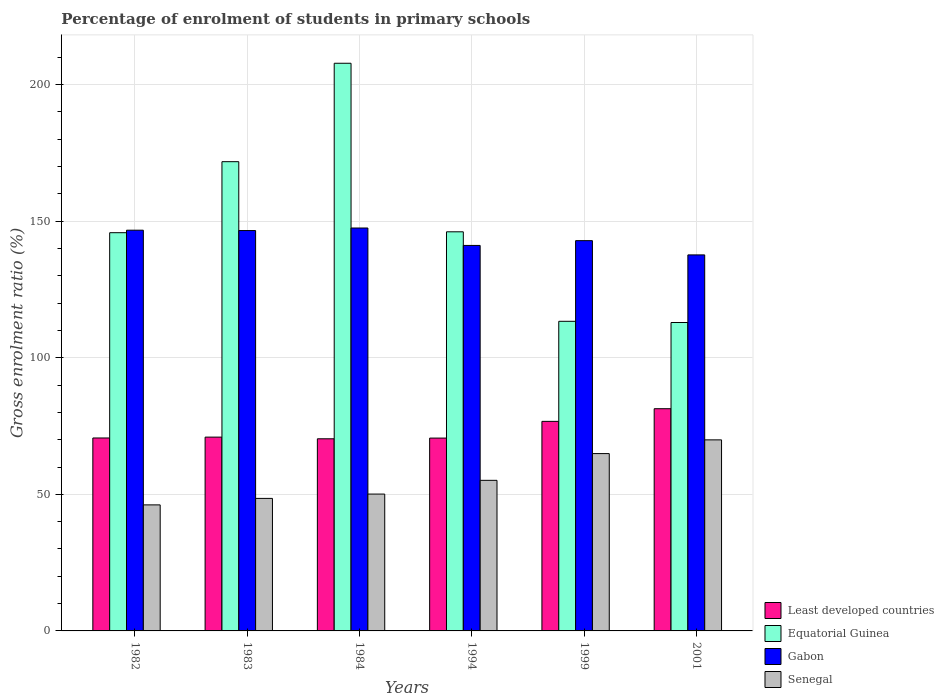How many groups of bars are there?
Your answer should be very brief. 6. Are the number of bars per tick equal to the number of legend labels?
Make the answer very short. Yes. Are the number of bars on each tick of the X-axis equal?
Keep it short and to the point. Yes. How many bars are there on the 6th tick from the left?
Your response must be concise. 4. How many bars are there on the 6th tick from the right?
Your response must be concise. 4. What is the label of the 3rd group of bars from the left?
Make the answer very short. 1984. In how many cases, is the number of bars for a given year not equal to the number of legend labels?
Ensure brevity in your answer.  0. What is the percentage of students enrolled in primary schools in Equatorial Guinea in 1982?
Offer a very short reply. 145.78. Across all years, what is the maximum percentage of students enrolled in primary schools in Equatorial Guinea?
Your response must be concise. 207.82. Across all years, what is the minimum percentage of students enrolled in primary schools in Equatorial Guinea?
Offer a terse response. 112.91. In which year was the percentage of students enrolled in primary schools in Senegal maximum?
Offer a very short reply. 2001. What is the total percentage of students enrolled in primary schools in Least developed countries in the graph?
Offer a very short reply. 440.58. What is the difference between the percentage of students enrolled in primary schools in Least developed countries in 1984 and that in 1999?
Offer a very short reply. -6.38. What is the difference between the percentage of students enrolled in primary schools in Least developed countries in 2001 and the percentage of students enrolled in primary schools in Senegal in 1999?
Make the answer very short. 16.43. What is the average percentage of students enrolled in primary schools in Equatorial Guinea per year?
Your response must be concise. 149.62. In the year 1999, what is the difference between the percentage of students enrolled in primary schools in Least developed countries and percentage of students enrolled in primary schools in Senegal?
Provide a succinct answer. 11.8. What is the ratio of the percentage of students enrolled in primary schools in Senegal in 1982 to that in 1994?
Keep it short and to the point. 0.84. Is the percentage of students enrolled in primary schools in Least developed countries in 1982 less than that in 1984?
Your answer should be compact. No. Is the difference between the percentage of students enrolled in primary schools in Least developed countries in 1984 and 2001 greater than the difference between the percentage of students enrolled in primary schools in Senegal in 1984 and 2001?
Provide a short and direct response. Yes. What is the difference between the highest and the second highest percentage of students enrolled in primary schools in Equatorial Guinea?
Keep it short and to the point. 36.03. What is the difference between the highest and the lowest percentage of students enrolled in primary schools in Least developed countries?
Offer a terse response. 11.01. What does the 2nd bar from the left in 1982 represents?
Keep it short and to the point. Equatorial Guinea. What does the 2nd bar from the right in 1982 represents?
Provide a succinct answer. Gabon. How many bars are there?
Keep it short and to the point. 24. Does the graph contain grids?
Ensure brevity in your answer.  Yes. Where does the legend appear in the graph?
Ensure brevity in your answer.  Bottom right. How are the legend labels stacked?
Your answer should be very brief. Vertical. What is the title of the graph?
Offer a very short reply. Percentage of enrolment of students in primary schools. What is the label or title of the X-axis?
Provide a succinct answer. Years. What is the Gross enrolment ratio (%) of Least developed countries in 1982?
Provide a short and direct response. 70.63. What is the Gross enrolment ratio (%) in Equatorial Guinea in 1982?
Offer a terse response. 145.78. What is the Gross enrolment ratio (%) of Gabon in 1982?
Make the answer very short. 146.7. What is the Gross enrolment ratio (%) in Senegal in 1982?
Your response must be concise. 46.14. What is the Gross enrolment ratio (%) of Least developed countries in 1983?
Your answer should be compact. 70.95. What is the Gross enrolment ratio (%) in Equatorial Guinea in 1983?
Keep it short and to the point. 171.78. What is the Gross enrolment ratio (%) of Gabon in 1983?
Your answer should be compact. 146.57. What is the Gross enrolment ratio (%) of Senegal in 1983?
Your response must be concise. 48.52. What is the Gross enrolment ratio (%) in Least developed countries in 1984?
Make the answer very short. 70.34. What is the Gross enrolment ratio (%) in Equatorial Guinea in 1984?
Your response must be concise. 207.82. What is the Gross enrolment ratio (%) in Gabon in 1984?
Keep it short and to the point. 147.5. What is the Gross enrolment ratio (%) in Senegal in 1984?
Provide a succinct answer. 50.1. What is the Gross enrolment ratio (%) in Least developed countries in 1994?
Keep it short and to the point. 70.6. What is the Gross enrolment ratio (%) in Equatorial Guinea in 1994?
Make the answer very short. 146.11. What is the Gross enrolment ratio (%) in Gabon in 1994?
Your answer should be very brief. 141.12. What is the Gross enrolment ratio (%) in Senegal in 1994?
Your answer should be compact. 55.13. What is the Gross enrolment ratio (%) of Least developed countries in 1999?
Offer a very short reply. 76.72. What is the Gross enrolment ratio (%) of Equatorial Guinea in 1999?
Give a very brief answer. 113.34. What is the Gross enrolment ratio (%) of Gabon in 1999?
Provide a succinct answer. 142.87. What is the Gross enrolment ratio (%) in Senegal in 1999?
Make the answer very short. 64.92. What is the Gross enrolment ratio (%) of Least developed countries in 2001?
Offer a terse response. 81.35. What is the Gross enrolment ratio (%) in Equatorial Guinea in 2001?
Make the answer very short. 112.91. What is the Gross enrolment ratio (%) in Gabon in 2001?
Ensure brevity in your answer.  137.66. What is the Gross enrolment ratio (%) of Senegal in 2001?
Your answer should be compact. 69.94. Across all years, what is the maximum Gross enrolment ratio (%) of Least developed countries?
Offer a very short reply. 81.35. Across all years, what is the maximum Gross enrolment ratio (%) of Equatorial Guinea?
Your answer should be compact. 207.82. Across all years, what is the maximum Gross enrolment ratio (%) of Gabon?
Offer a very short reply. 147.5. Across all years, what is the maximum Gross enrolment ratio (%) in Senegal?
Provide a short and direct response. 69.94. Across all years, what is the minimum Gross enrolment ratio (%) in Least developed countries?
Your answer should be compact. 70.34. Across all years, what is the minimum Gross enrolment ratio (%) of Equatorial Guinea?
Make the answer very short. 112.91. Across all years, what is the minimum Gross enrolment ratio (%) of Gabon?
Give a very brief answer. 137.66. Across all years, what is the minimum Gross enrolment ratio (%) in Senegal?
Ensure brevity in your answer.  46.14. What is the total Gross enrolment ratio (%) of Least developed countries in the graph?
Your response must be concise. 440.58. What is the total Gross enrolment ratio (%) of Equatorial Guinea in the graph?
Give a very brief answer. 897.75. What is the total Gross enrolment ratio (%) of Gabon in the graph?
Your answer should be compact. 862.43. What is the total Gross enrolment ratio (%) in Senegal in the graph?
Give a very brief answer. 334.74. What is the difference between the Gross enrolment ratio (%) in Least developed countries in 1982 and that in 1983?
Your response must be concise. -0.32. What is the difference between the Gross enrolment ratio (%) of Equatorial Guinea in 1982 and that in 1983?
Your response must be concise. -26. What is the difference between the Gross enrolment ratio (%) in Gabon in 1982 and that in 1983?
Ensure brevity in your answer.  0.13. What is the difference between the Gross enrolment ratio (%) of Senegal in 1982 and that in 1983?
Your answer should be very brief. -2.37. What is the difference between the Gross enrolment ratio (%) of Least developed countries in 1982 and that in 1984?
Your answer should be compact. 0.3. What is the difference between the Gross enrolment ratio (%) in Equatorial Guinea in 1982 and that in 1984?
Offer a very short reply. -62.03. What is the difference between the Gross enrolment ratio (%) in Gabon in 1982 and that in 1984?
Offer a very short reply. -0.8. What is the difference between the Gross enrolment ratio (%) in Senegal in 1982 and that in 1984?
Give a very brief answer. -3.96. What is the difference between the Gross enrolment ratio (%) in Least developed countries in 1982 and that in 1994?
Offer a very short reply. 0.04. What is the difference between the Gross enrolment ratio (%) in Equatorial Guinea in 1982 and that in 1994?
Give a very brief answer. -0.33. What is the difference between the Gross enrolment ratio (%) in Gabon in 1982 and that in 1994?
Make the answer very short. 5.58. What is the difference between the Gross enrolment ratio (%) of Senegal in 1982 and that in 1994?
Provide a succinct answer. -8.99. What is the difference between the Gross enrolment ratio (%) in Least developed countries in 1982 and that in 1999?
Your response must be concise. -6.08. What is the difference between the Gross enrolment ratio (%) in Equatorial Guinea in 1982 and that in 1999?
Ensure brevity in your answer.  32.44. What is the difference between the Gross enrolment ratio (%) in Gabon in 1982 and that in 1999?
Ensure brevity in your answer.  3.83. What is the difference between the Gross enrolment ratio (%) of Senegal in 1982 and that in 1999?
Provide a short and direct response. -18.78. What is the difference between the Gross enrolment ratio (%) of Least developed countries in 1982 and that in 2001?
Your answer should be very brief. -10.72. What is the difference between the Gross enrolment ratio (%) in Equatorial Guinea in 1982 and that in 2001?
Make the answer very short. 32.88. What is the difference between the Gross enrolment ratio (%) in Gabon in 1982 and that in 2001?
Offer a terse response. 9.05. What is the difference between the Gross enrolment ratio (%) in Senegal in 1982 and that in 2001?
Provide a short and direct response. -23.8. What is the difference between the Gross enrolment ratio (%) in Least developed countries in 1983 and that in 1984?
Your answer should be compact. 0.61. What is the difference between the Gross enrolment ratio (%) in Equatorial Guinea in 1983 and that in 1984?
Provide a short and direct response. -36.03. What is the difference between the Gross enrolment ratio (%) of Gabon in 1983 and that in 1984?
Offer a terse response. -0.93. What is the difference between the Gross enrolment ratio (%) in Senegal in 1983 and that in 1984?
Your answer should be compact. -1.59. What is the difference between the Gross enrolment ratio (%) in Least developed countries in 1983 and that in 1994?
Your answer should be very brief. 0.35. What is the difference between the Gross enrolment ratio (%) in Equatorial Guinea in 1983 and that in 1994?
Offer a terse response. 25.67. What is the difference between the Gross enrolment ratio (%) in Gabon in 1983 and that in 1994?
Your response must be concise. 5.45. What is the difference between the Gross enrolment ratio (%) of Senegal in 1983 and that in 1994?
Your answer should be very brief. -6.61. What is the difference between the Gross enrolment ratio (%) of Least developed countries in 1983 and that in 1999?
Offer a terse response. -5.76. What is the difference between the Gross enrolment ratio (%) in Equatorial Guinea in 1983 and that in 1999?
Ensure brevity in your answer.  58.44. What is the difference between the Gross enrolment ratio (%) of Gabon in 1983 and that in 1999?
Provide a short and direct response. 3.7. What is the difference between the Gross enrolment ratio (%) of Senegal in 1983 and that in 1999?
Your answer should be compact. -16.4. What is the difference between the Gross enrolment ratio (%) of Least developed countries in 1983 and that in 2001?
Your answer should be compact. -10.4. What is the difference between the Gross enrolment ratio (%) of Equatorial Guinea in 1983 and that in 2001?
Your answer should be compact. 58.88. What is the difference between the Gross enrolment ratio (%) in Gabon in 1983 and that in 2001?
Offer a very short reply. 8.92. What is the difference between the Gross enrolment ratio (%) of Senegal in 1983 and that in 2001?
Your answer should be very brief. -21.43. What is the difference between the Gross enrolment ratio (%) in Least developed countries in 1984 and that in 1994?
Give a very brief answer. -0.26. What is the difference between the Gross enrolment ratio (%) of Equatorial Guinea in 1984 and that in 1994?
Offer a terse response. 61.7. What is the difference between the Gross enrolment ratio (%) of Gabon in 1984 and that in 1994?
Ensure brevity in your answer.  6.38. What is the difference between the Gross enrolment ratio (%) in Senegal in 1984 and that in 1994?
Your answer should be compact. -5.02. What is the difference between the Gross enrolment ratio (%) of Least developed countries in 1984 and that in 1999?
Provide a short and direct response. -6.38. What is the difference between the Gross enrolment ratio (%) in Equatorial Guinea in 1984 and that in 1999?
Provide a short and direct response. 94.47. What is the difference between the Gross enrolment ratio (%) of Gabon in 1984 and that in 1999?
Offer a terse response. 4.63. What is the difference between the Gross enrolment ratio (%) in Senegal in 1984 and that in 1999?
Keep it short and to the point. -14.82. What is the difference between the Gross enrolment ratio (%) in Least developed countries in 1984 and that in 2001?
Keep it short and to the point. -11.01. What is the difference between the Gross enrolment ratio (%) of Equatorial Guinea in 1984 and that in 2001?
Ensure brevity in your answer.  94.91. What is the difference between the Gross enrolment ratio (%) of Gabon in 1984 and that in 2001?
Ensure brevity in your answer.  9.85. What is the difference between the Gross enrolment ratio (%) of Senegal in 1984 and that in 2001?
Your answer should be very brief. -19.84. What is the difference between the Gross enrolment ratio (%) in Least developed countries in 1994 and that in 1999?
Your response must be concise. -6.12. What is the difference between the Gross enrolment ratio (%) of Equatorial Guinea in 1994 and that in 1999?
Provide a succinct answer. 32.77. What is the difference between the Gross enrolment ratio (%) in Gabon in 1994 and that in 1999?
Make the answer very short. -1.75. What is the difference between the Gross enrolment ratio (%) of Senegal in 1994 and that in 1999?
Your answer should be very brief. -9.79. What is the difference between the Gross enrolment ratio (%) in Least developed countries in 1994 and that in 2001?
Your response must be concise. -10.75. What is the difference between the Gross enrolment ratio (%) in Equatorial Guinea in 1994 and that in 2001?
Make the answer very short. 33.21. What is the difference between the Gross enrolment ratio (%) in Gabon in 1994 and that in 2001?
Ensure brevity in your answer.  3.47. What is the difference between the Gross enrolment ratio (%) in Senegal in 1994 and that in 2001?
Ensure brevity in your answer.  -14.82. What is the difference between the Gross enrolment ratio (%) of Least developed countries in 1999 and that in 2001?
Offer a terse response. -4.63. What is the difference between the Gross enrolment ratio (%) in Equatorial Guinea in 1999 and that in 2001?
Offer a very short reply. 0.44. What is the difference between the Gross enrolment ratio (%) in Gabon in 1999 and that in 2001?
Your answer should be compact. 5.22. What is the difference between the Gross enrolment ratio (%) in Senegal in 1999 and that in 2001?
Offer a terse response. -5.02. What is the difference between the Gross enrolment ratio (%) of Least developed countries in 1982 and the Gross enrolment ratio (%) of Equatorial Guinea in 1983?
Your response must be concise. -101.15. What is the difference between the Gross enrolment ratio (%) of Least developed countries in 1982 and the Gross enrolment ratio (%) of Gabon in 1983?
Give a very brief answer. -75.94. What is the difference between the Gross enrolment ratio (%) of Least developed countries in 1982 and the Gross enrolment ratio (%) of Senegal in 1983?
Provide a short and direct response. 22.12. What is the difference between the Gross enrolment ratio (%) in Equatorial Guinea in 1982 and the Gross enrolment ratio (%) in Gabon in 1983?
Keep it short and to the point. -0.79. What is the difference between the Gross enrolment ratio (%) in Equatorial Guinea in 1982 and the Gross enrolment ratio (%) in Senegal in 1983?
Provide a short and direct response. 97.27. What is the difference between the Gross enrolment ratio (%) in Gabon in 1982 and the Gross enrolment ratio (%) in Senegal in 1983?
Your response must be concise. 98.19. What is the difference between the Gross enrolment ratio (%) of Least developed countries in 1982 and the Gross enrolment ratio (%) of Equatorial Guinea in 1984?
Your answer should be compact. -137.18. What is the difference between the Gross enrolment ratio (%) of Least developed countries in 1982 and the Gross enrolment ratio (%) of Gabon in 1984?
Make the answer very short. -76.87. What is the difference between the Gross enrolment ratio (%) in Least developed countries in 1982 and the Gross enrolment ratio (%) in Senegal in 1984?
Your response must be concise. 20.53. What is the difference between the Gross enrolment ratio (%) in Equatorial Guinea in 1982 and the Gross enrolment ratio (%) in Gabon in 1984?
Give a very brief answer. -1.72. What is the difference between the Gross enrolment ratio (%) of Equatorial Guinea in 1982 and the Gross enrolment ratio (%) of Senegal in 1984?
Provide a succinct answer. 95.68. What is the difference between the Gross enrolment ratio (%) of Gabon in 1982 and the Gross enrolment ratio (%) of Senegal in 1984?
Your answer should be compact. 96.6. What is the difference between the Gross enrolment ratio (%) of Least developed countries in 1982 and the Gross enrolment ratio (%) of Equatorial Guinea in 1994?
Your answer should be very brief. -75.48. What is the difference between the Gross enrolment ratio (%) of Least developed countries in 1982 and the Gross enrolment ratio (%) of Gabon in 1994?
Ensure brevity in your answer.  -70.49. What is the difference between the Gross enrolment ratio (%) in Least developed countries in 1982 and the Gross enrolment ratio (%) in Senegal in 1994?
Offer a very short reply. 15.51. What is the difference between the Gross enrolment ratio (%) of Equatorial Guinea in 1982 and the Gross enrolment ratio (%) of Gabon in 1994?
Ensure brevity in your answer.  4.66. What is the difference between the Gross enrolment ratio (%) in Equatorial Guinea in 1982 and the Gross enrolment ratio (%) in Senegal in 1994?
Offer a very short reply. 90.66. What is the difference between the Gross enrolment ratio (%) in Gabon in 1982 and the Gross enrolment ratio (%) in Senegal in 1994?
Your answer should be compact. 91.58. What is the difference between the Gross enrolment ratio (%) of Least developed countries in 1982 and the Gross enrolment ratio (%) of Equatorial Guinea in 1999?
Offer a very short reply. -42.71. What is the difference between the Gross enrolment ratio (%) in Least developed countries in 1982 and the Gross enrolment ratio (%) in Gabon in 1999?
Provide a short and direct response. -72.24. What is the difference between the Gross enrolment ratio (%) of Least developed countries in 1982 and the Gross enrolment ratio (%) of Senegal in 1999?
Offer a very short reply. 5.71. What is the difference between the Gross enrolment ratio (%) of Equatorial Guinea in 1982 and the Gross enrolment ratio (%) of Gabon in 1999?
Keep it short and to the point. 2.91. What is the difference between the Gross enrolment ratio (%) in Equatorial Guinea in 1982 and the Gross enrolment ratio (%) in Senegal in 1999?
Offer a very short reply. 80.87. What is the difference between the Gross enrolment ratio (%) of Gabon in 1982 and the Gross enrolment ratio (%) of Senegal in 1999?
Ensure brevity in your answer.  81.79. What is the difference between the Gross enrolment ratio (%) in Least developed countries in 1982 and the Gross enrolment ratio (%) in Equatorial Guinea in 2001?
Make the answer very short. -42.27. What is the difference between the Gross enrolment ratio (%) of Least developed countries in 1982 and the Gross enrolment ratio (%) of Gabon in 2001?
Keep it short and to the point. -67.02. What is the difference between the Gross enrolment ratio (%) of Least developed countries in 1982 and the Gross enrolment ratio (%) of Senegal in 2001?
Ensure brevity in your answer.  0.69. What is the difference between the Gross enrolment ratio (%) of Equatorial Guinea in 1982 and the Gross enrolment ratio (%) of Gabon in 2001?
Ensure brevity in your answer.  8.13. What is the difference between the Gross enrolment ratio (%) in Equatorial Guinea in 1982 and the Gross enrolment ratio (%) in Senegal in 2001?
Make the answer very short. 75.84. What is the difference between the Gross enrolment ratio (%) of Gabon in 1982 and the Gross enrolment ratio (%) of Senegal in 2001?
Give a very brief answer. 76.76. What is the difference between the Gross enrolment ratio (%) in Least developed countries in 1983 and the Gross enrolment ratio (%) in Equatorial Guinea in 1984?
Give a very brief answer. -136.86. What is the difference between the Gross enrolment ratio (%) in Least developed countries in 1983 and the Gross enrolment ratio (%) in Gabon in 1984?
Give a very brief answer. -76.55. What is the difference between the Gross enrolment ratio (%) of Least developed countries in 1983 and the Gross enrolment ratio (%) of Senegal in 1984?
Make the answer very short. 20.85. What is the difference between the Gross enrolment ratio (%) in Equatorial Guinea in 1983 and the Gross enrolment ratio (%) in Gabon in 1984?
Give a very brief answer. 24.28. What is the difference between the Gross enrolment ratio (%) of Equatorial Guinea in 1983 and the Gross enrolment ratio (%) of Senegal in 1984?
Your answer should be compact. 121.68. What is the difference between the Gross enrolment ratio (%) of Gabon in 1983 and the Gross enrolment ratio (%) of Senegal in 1984?
Offer a very short reply. 96.47. What is the difference between the Gross enrolment ratio (%) of Least developed countries in 1983 and the Gross enrolment ratio (%) of Equatorial Guinea in 1994?
Make the answer very short. -75.16. What is the difference between the Gross enrolment ratio (%) of Least developed countries in 1983 and the Gross enrolment ratio (%) of Gabon in 1994?
Give a very brief answer. -70.17. What is the difference between the Gross enrolment ratio (%) in Least developed countries in 1983 and the Gross enrolment ratio (%) in Senegal in 1994?
Keep it short and to the point. 15.82. What is the difference between the Gross enrolment ratio (%) of Equatorial Guinea in 1983 and the Gross enrolment ratio (%) of Gabon in 1994?
Your answer should be compact. 30.66. What is the difference between the Gross enrolment ratio (%) in Equatorial Guinea in 1983 and the Gross enrolment ratio (%) in Senegal in 1994?
Keep it short and to the point. 116.66. What is the difference between the Gross enrolment ratio (%) in Gabon in 1983 and the Gross enrolment ratio (%) in Senegal in 1994?
Your response must be concise. 91.45. What is the difference between the Gross enrolment ratio (%) of Least developed countries in 1983 and the Gross enrolment ratio (%) of Equatorial Guinea in 1999?
Ensure brevity in your answer.  -42.39. What is the difference between the Gross enrolment ratio (%) of Least developed countries in 1983 and the Gross enrolment ratio (%) of Gabon in 1999?
Give a very brief answer. -71.92. What is the difference between the Gross enrolment ratio (%) in Least developed countries in 1983 and the Gross enrolment ratio (%) in Senegal in 1999?
Keep it short and to the point. 6.03. What is the difference between the Gross enrolment ratio (%) in Equatorial Guinea in 1983 and the Gross enrolment ratio (%) in Gabon in 1999?
Provide a short and direct response. 28.91. What is the difference between the Gross enrolment ratio (%) in Equatorial Guinea in 1983 and the Gross enrolment ratio (%) in Senegal in 1999?
Provide a short and direct response. 106.86. What is the difference between the Gross enrolment ratio (%) in Gabon in 1983 and the Gross enrolment ratio (%) in Senegal in 1999?
Keep it short and to the point. 81.65. What is the difference between the Gross enrolment ratio (%) of Least developed countries in 1983 and the Gross enrolment ratio (%) of Equatorial Guinea in 2001?
Offer a terse response. -41.95. What is the difference between the Gross enrolment ratio (%) of Least developed countries in 1983 and the Gross enrolment ratio (%) of Gabon in 2001?
Offer a terse response. -66.71. What is the difference between the Gross enrolment ratio (%) of Least developed countries in 1983 and the Gross enrolment ratio (%) of Senegal in 2001?
Your answer should be compact. 1.01. What is the difference between the Gross enrolment ratio (%) of Equatorial Guinea in 1983 and the Gross enrolment ratio (%) of Gabon in 2001?
Your response must be concise. 34.13. What is the difference between the Gross enrolment ratio (%) of Equatorial Guinea in 1983 and the Gross enrolment ratio (%) of Senegal in 2001?
Make the answer very short. 101.84. What is the difference between the Gross enrolment ratio (%) of Gabon in 1983 and the Gross enrolment ratio (%) of Senegal in 2001?
Keep it short and to the point. 76.63. What is the difference between the Gross enrolment ratio (%) in Least developed countries in 1984 and the Gross enrolment ratio (%) in Equatorial Guinea in 1994?
Provide a short and direct response. -75.78. What is the difference between the Gross enrolment ratio (%) in Least developed countries in 1984 and the Gross enrolment ratio (%) in Gabon in 1994?
Your answer should be very brief. -70.79. What is the difference between the Gross enrolment ratio (%) of Least developed countries in 1984 and the Gross enrolment ratio (%) of Senegal in 1994?
Provide a short and direct response. 15.21. What is the difference between the Gross enrolment ratio (%) of Equatorial Guinea in 1984 and the Gross enrolment ratio (%) of Gabon in 1994?
Offer a terse response. 66.69. What is the difference between the Gross enrolment ratio (%) of Equatorial Guinea in 1984 and the Gross enrolment ratio (%) of Senegal in 1994?
Your answer should be compact. 152.69. What is the difference between the Gross enrolment ratio (%) of Gabon in 1984 and the Gross enrolment ratio (%) of Senegal in 1994?
Ensure brevity in your answer.  92.38. What is the difference between the Gross enrolment ratio (%) of Least developed countries in 1984 and the Gross enrolment ratio (%) of Equatorial Guinea in 1999?
Ensure brevity in your answer.  -43.01. What is the difference between the Gross enrolment ratio (%) of Least developed countries in 1984 and the Gross enrolment ratio (%) of Gabon in 1999?
Keep it short and to the point. -72.54. What is the difference between the Gross enrolment ratio (%) in Least developed countries in 1984 and the Gross enrolment ratio (%) in Senegal in 1999?
Your answer should be very brief. 5.42. What is the difference between the Gross enrolment ratio (%) in Equatorial Guinea in 1984 and the Gross enrolment ratio (%) in Gabon in 1999?
Make the answer very short. 64.94. What is the difference between the Gross enrolment ratio (%) of Equatorial Guinea in 1984 and the Gross enrolment ratio (%) of Senegal in 1999?
Ensure brevity in your answer.  142.9. What is the difference between the Gross enrolment ratio (%) in Gabon in 1984 and the Gross enrolment ratio (%) in Senegal in 1999?
Offer a terse response. 82.58. What is the difference between the Gross enrolment ratio (%) in Least developed countries in 1984 and the Gross enrolment ratio (%) in Equatorial Guinea in 2001?
Your answer should be very brief. -42.57. What is the difference between the Gross enrolment ratio (%) of Least developed countries in 1984 and the Gross enrolment ratio (%) of Gabon in 2001?
Keep it short and to the point. -67.32. What is the difference between the Gross enrolment ratio (%) in Least developed countries in 1984 and the Gross enrolment ratio (%) in Senegal in 2001?
Make the answer very short. 0.39. What is the difference between the Gross enrolment ratio (%) of Equatorial Guinea in 1984 and the Gross enrolment ratio (%) of Gabon in 2001?
Your answer should be compact. 70.16. What is the difference between the Gross enrolment ratio (%) of Equatorial Guinea in 1984 and the Gross enrolment ratio (%) of Senegal in 2001?
Your answer should be compact. 137.87. What is the difference between the Gross enrolment ratio (%) of Gabon in 1984 and the Gross enrolment ratio (%) of Senegal in 2001?
Provide a succinct answer. 77.56. What is the difference between the Gross enrolment ratio (%) in Least developed countries in 1994 and the Gross enrolment ratio (%) in Equatorial Guinea in 1999?
Your answer should be compact. -42.75. What is the difference between the Gross enrolment ratio (%) of Least developed countries in 1994 and the Gross enrolment ratio (%) of Gabon in 1999?
Keep it short and to the point. -72.28. What is the difference between the Gross enrolment ratio (%) of Least developed countries in 1994 and the Gross enrolment ratio (%) of Senegal in 1999?
Ensure brevity in your answer.  5.68. What is the difference between the Gross enrolment ratio (%) of Equatorial Guinea in 1994 and the Gross enrolment ratio (%) of Gabon in 1999?
Offer a terse response. 3.24. What is the difference between the Gross enrolment ratio (%) in Equatorial Guinea in 1994 and the Gross enrolment ratio (%) in Senegal in 1999?
Your answer should be compact. 81.19. What is the difference between the Gross enrolment ratio (%) of Gabon in 1994 and the Gross enrolment ratio (%) of Senegal in 1999?
Ensure brevity in your answer.  76.2. What is the difference between the Gross enrolment ratio (%) of Least developed countries in 1994 and the Gross enrolment ratio (%) of Equatorial Guinea in 2001?
Keep it short and to the point. -42.31. What is the difference between the Gross enrolment ratio (%) of Least developed countries in 1994 and the Gross enrolment ratio (%) of Gabon in 2001?
Ensure brevity in your answer.  -67.06. What is the difference between the Gross enrolment ratio (%) of Least developed countries in 1994 and the Gross enrolment ratio (%) of Senegal in 2001?
Offer a very short reply. 0.66. What is the difference between the Gross enrolment ratio (%) in Equatorial Guinea in 1994 and the Gross enrolment ratio (%) in Gabon in 2001?
Your response must be concise. 8.46. What is the difference between the Gross enrolment ratio (%) of Equatorial Guinea in 1994 and the Gross enrolment ratio (%) of Senegal in 2001?
Give a very brief answer. 76.17. What is the difference between the Gross enrolment ratio (%) of Gabon in 1994 and the Gross enrolment ratio (%) of Senegal in 2001?
Provide a succinct answer. 71.18. What is the difference between the Gross enrolment ratio (%) in Least developed countries in 1999 and the Gross enrolment ratio (%) in Equatorial Guinea in 2001?
Your answer should be very brief. -36.19. What is the difference between the Gross enrolment ratio (%) of Least developed countries in 1999 and the Gross enrolment ratio (%) of Gabon in 2001?
Keep it short and to the point. -60.94. What is the difference between the Gross enrolment ratio (%) in Least developed countries in 1999 and the Gross enrolment ratio (%) in Senegal in 2001?
Make the answer very short. 6.77. What is the difference between the Gross enrolment ratio (%) in Equatorial Guinea in 1999 and the Gross enrolment ratio (%) in Gabon in 2001?
Make the answer very short. -24.31. What is the difference between the Gross enrolment ratio (%) in Equatorial Guinea in 1999 and the Gross enrolment ratio (%) in Senegal in 2001?
Make the answer very short. 43.4. What is the difference between the Gross enrolment ratio (%) in Gabon in 1999 and the Gross enrolment ratio (%) in Senegal in 2001?
Give a very brief answer. 72.93. What is the average Gross enrolment ratio (%) of Least developed countries per year?
Ensure brevity in your answer.  73.43. What is the average Gross enrolment ratio (%) of Equatorial Guinea per year?
Offer a very short reply. 149.62. What is the average Gross enrolment ratio (%) of Gabon per year?
Give a very brief answer. 143.74. What is the average Gross enrolment ratio (%) in Senegal per year?
Give a very brief answer. 55.79. In the year 1982, what is the difference between the Gross enrolment ratio (%) of Least developed countries and Gross enrolment ratio (%) of Equatorial Guinea?
Provide a short and direct response. -75.15. In the year 1982, what is the difference between the Gross enrolment ratio (%) of Least developed countries and Gross enrolment ratio (%) of Gabon?
Give a very brief answer. -76.07. In the year 1982, what is the difference between the Gross enrolment ratio (%) in Least developed countries and Gross enrolment ratio (%) in Senegal?
Your response must be concise. 24.49. In the year 1982, what is the difference between the Gross enrolment ratio (%) in Equatorial Guinea and Gross enrolment ratio (%) in Gabon?
Your answer should be very brief. -0.92. In the year 1982, what is the difference between the Gross enrolment ratio (%) in Equatorial Guinea and Gross enrolment ratio (%) in Senegal?
Your answer should be very brief. 99.64. In the year 1982, what is the difference between the Gross enrolment ratio (%) of Gabon and Gross enrolment ratio (%) of Senegal?
Offer a very short reply. 100.56. In the year 1983, what is the difference between the Gross enrolment ratio (%) of Least developed countries and Gross enrolment ratio (%) of Equatorial Guinea?
Offer a terse response. -100.83. In the year 1983, what is the difference between the Gross enrolment ratio (%) of Least developed countries and Gross enrolment ratio (%) of Gabon?
Keep it short and to the point. -75.62. In the year 1983, what is the difference between the Gross enrolment ratio (%) in Least developed countries and Gross enrolment ratio (%) in Senegal?
Offer a very short reply. 22.44. In the year 1983, what is the difference between the Gross enrolment ratio (%) in Equatorial Guinea and Gross enrolment ratio (%) in Gabon?
Offer a terse response. 25.21. In the year 1983, what is the difference between the Gross enrolment ratio (%) in Equatorial Guinea and Gross enrolment ratio (%) in Senegal?
Offer a very short reply. 123.27. In the year 1983, what is the difference between the Gross enrolment ratio (%) of Gabon and Gross enrolment ratio (%) of Senegal?
Your response must be concise. 98.06. In the year 1984, what is the difference between the Gross enrolment ratio (%) of Least developed countries and Gross enrolment ratio (%) of Equatorial Guinea?
Your response must be concise. -137.48. In the year 1984, what is the difference between the Gross enrolment ratio (%) in Least developed countries and Gross enrolment ratio (%) in Gabon?
Offer a terse response. -77.17. In the year 1984, what is the difference between the Gross enrolment ratio (%) in Least developed countries and Gross enrolment ratio (%) in Senegal?
Make the answer very short. 20.23. In the year 1984, what is the difference between the Gross enrolment ratio (%) of Equatorial Guinea and Gross enrolment ratio (%) of Gabon?
Provide a short and direct response. 60.31. In the year 1984, what is the difference between the Gross enrolment ratio (%) of Equatorial Guinea and Gross enrolment ratio (%) of Senegal?
Provide a short and direct response. 157.71. In the year 1984, what is the difference between the Gross enrolment ratio (%) in Gabon and Gross enrolment ratio (%) in Senegal?
Offer a terse response. 97.4. In the year 1994, what is the difference between the Gross enrolment ratio (%) in Least developed countries and Gross enrolment ratio (%) in Equatorial Guinea?
Make the answer very short. -75.52. In the year 1994, what is the difference between the Gross enrolment ratio (%) in Least developed countries and Gross enrolment ratio (%) in Gabon?
Offer a very short reply. -70.53. In the year 1994, what is the difference between the Gross enrolment ratio (%) of Least developed countries and Gross enrolment ratio (%) of Senegal?
Your answer should be very brief. 15.47. In the year 1994, what is the difference between the Gross enrolment ratio (%) of Equatorial Guinea and Gross enrolment ratio (%) of Gabon?
Provide a succinct answer. 4.99. In the year 1994, what is the difference between the Gross enrolment ratio (%) of Equatorial Guinea and Gross enrolment ratio (%) of Senegal?
Your answer should be very brief. 90.99. In the year 1994, what is the difference between the Gross enrolment ratio (%) in Gabon and Gross enrolment ratio (%) in Senegal?
Offer a very short reply. 86. In the year 1999, what is the difference between the Gross enrolment ratio (%) of Least developed countries and Gross enrolment ratio (%) of Equatorial Guinea?
Make the answer very short. -36.63. In the year 1999, what is the difference between the Gross enrolment ratio (%) of Least developed countries and Gross enrolment ratio (%) of Gabon?
Keep it short and to the point. -66.16. In the year 1999, what is the difference between the Gross enrolment ratio (%) in Least developed countries and Gross enrolment ratio (%) in Senegal?
Give a very brief answer. 11.8. In the year 1999, what is the difference between the Gross enrolment ratio (%) in Equatorial Guinea and Gross enrolment ratio (%) in Gabon?
Offer a terse response. -29.53. In the year 1999, what is the difference between the Gross enrolment ratio (%) of Equatorial Guinea and Gross enrolment ratio (%) of Senegal?
Your response must be concise. 48.43. In the year 1999, what is the difference between the Gross enrolment ratio (%) in Gabon and Gross enrolment ratio (%) in Senegal?
Your answer should be very brief. 77.96. In the year 2001, what is the difference between the Gross enrolment ratio (%) in Least developed countries and Gross enrolment ratio (%) in Equatorial Guinea?
Your answer should be compact. -31.56. In the year 2001, what is the difference between the Gross enrolment ratio (%) in Least developed countries and Gross enrolment ratio (%) in Gabon?
Provide a succinct answer. -56.31. In the year 2001, what is the difference between the Gross enrolment ratio (%) in Least developed countries and Gross enrolment ratio (%) in Senegal?
Your answer should be compact. 11.41. In the year 2001, what is the difference between the Gross enrolment ratio (%) in Equatorial Guinea and Gross enrolment ratio (%) in Gabon?
Offer a very short reply. -24.75. In the year 2001, what is the difference between the Gross enrolment ratio (%) in Equatorial Guinea and Gross enrolment ratio (%) in Senegal?
Give a very brief answer. 42.96. In the year 2001, what is the difference between the Gross enrolment ratio (%) of Gabon and Gross enrolment ratio (%) of Senegal?
Offer a very short reply. 67.71. What is the ratio of the Gross enrolment ratio (%) of Least developed countries in 1982 to that in 1983?
Provide a short and direct response. 1. What is the ratio of the Gross enrolment ratio (%) of Equatorial Guinea in 1982 to that in 1983?
Ensure brevity in your answer.  0.85. What is the ratio of the Gross enrolment ratio (%) in Gabon in 1982 to that in 1983?
Your answer should be compact. 1. What is the ratio of the Gross enrolment ratio (%) of Senegal in 1982 to that in 1983?
Make the answer very short. 0.95. What is the ratio of the Gross enrolment ratio (%) in Least developed countries in 1982 to that in 1984?
Your response must be concise. 1. What is the ratio of the Gross enrolment ratio (%) of Equatorial Guinea in 1982 to that in 1984?
Make the answer very short. 0.7. What is the ratio of the Gross enrolment ratio (%) in Gabon in 1982 to that in 1984?
Your answer should be very brief. 0.99. What is the ratio of the Gross enrolment ratio (%) of Senegal in 1982 to that in 1984?
Your answer should be compact. 0.92. What is the ratio of the Gross enrolment ratio (%) in Equatorial Guinea in 1982 to that in 1994?
Make the answer very short. 1. What is the ratio of the Gross enrolment ratio (%) in Gabon in 1982 to that in 1994?
Provide a short and direct response. 1.04. What is the ratio of the Gross enrolment ratio (%) of Senegal in 1982 to that in 1994?
Provide a short and direct response. 0.84. What is the ratio of the Gross enrolment ratio (%) of Least developed countries in 1982 to that in 1999?
Your answer should be very brief. 0.92. What is the ratio of the Gross enrolment ratio (%) in Equatorial Guinea in 1982 to that in 1999?
Offer a terse response. 1.29. What is the ratio of the Gross enrolment ratio (%) of Gabon in 1982 to that in 1999?
Offer a very short reply. 1.03. What is the ratio of the Gross enrolment ratio (%) in Senegal in 1982 to that in 1999?
Keep it short and to the point. 0.71. What is the ratio of the Gross enrolment ratio (%) in Least developed countries in 1982 to that in 2001?
Offer a very short reply. 0.87. What is the ratio of the Gross enrolment ratio (%) of Equatorial Guinea in 1982 to that in 2001?
Make the answer very short. 1.29. What is the ratio of the Gross enrolment ratio (%) in Gabon in 1982 to that in 2001?
Provide a succinct answer. 1.07. What is the ratio of the Gross enrolment ratio (%) of Senegal in 1982 to that in 2001?
Provide a short and direct response. 0.66. What is the ratio of the Gross enrolment ratio (%) in Least developed countries in 1983 to that in 1984?
Offer a terse response. 1.01. What is the ratio of the Gross enrolment ratio (%) of Equatorial Guinea in 1983 to that in 1984?
Give a very brief answer. 0.83. What is the ratio of the Gross enrolment ratio (%) of Gabon in 1983 to that in 1984?
Keep it short and to the point. 0.99. What is the ratio of the Gross enrolment ratio (%) of Senegal in 1983 to that in 1984?
Offer a terse response. 0.97. What is the ratio of the Gross enrolment ratio (%) in Equatorial Guinea in 1983 to that in 1994?
Your answer should be very brief. 1.18. What is the ratio of the Gross enrolment ratio (%) in Gabon in 1983 to that in 1994?
Provide a succinct answer. 1.04. What is the ratio of the Gross enrolment ratio (%) in Senegal in 1983 to that in 1994?
Make the answer very short. 0.88. What is the ratio of the Gross enrolment ratio (%) of Least developed countries in 1983 to that in 1999?
Your response must be concise. 0.92. What is the ratio of the Gross enrolment ratio (%) in Equatorial Guinea in 1983 to that in 1999?
Provide a short and direct response. 1.52. What is the ratio of the Gross enrolment ratio (%) in Gabon in 1983 to that in 1999?
Give a very brief answer. 1.03. What is the ratio of the Gross enrolment ratio (%) in Senegal in 1983 to that in 1999?
Provide a succinct answer. 0.75. What is the ratio of the Gross enrolment ratio (%) of Least developed countries in 1983 to that in 2001?
Your response must be concise. 0.87. What is the ratio of the Gross enrolment ratio (%) of Equatorial Guinea in 1983 to that in 2001?
Give a very brief answer. 1.52. What is the ratio of the Gross enrolment ratio (%) of Gabon in 1983 to that in 2001?
Your answer should be compact. 1.06. What is the ratio of the Gross enrolment ratio (%) of Senegal in 1983 to that in 2001?
Make the answer very short. 0.69. What is the ratio of the Gross enrolment ratio (%) of Least developed countries in 1984 to that in 1994?
Keep it short and to the point. 1. What is the ratio of the Gross enrolment ratio (%) of Equatorial Guinea in 1984 to that in 1994?
Make the answer very short. 1.42. What is the ratio of the Gross enrolment ratio (%) in Gabon in 1984 to that in 1994?
Your response must be concise. 1.05. What is the ratio of the Gross enrolment ratio (%) in Senegal in 1984 to that in 1994?
Keep it short and to the point. 0.91. What is the ratio of the Gross enrolment ratio (%) in Least developed countries in 1984 to that in 1999?
Provide a short and direct response. 0.92. What is the ratio of the Gross enrolment ratio (%) in Equatorial Guinea in 1984 to that in 1999?
Keep it short and to the point. 1.83. What is the ratio of the Gross enrolment ratio (%) in Gabon in 1984 to that in 1999?
Keep it short and to the point. 1.03. What is the ratio of the Gross enrolment ratio (%) in Senegal in 1984 to that in 1999?
Your answer should be very brief. 0.77. What is the ratio of the Gross enrolment ratio (%) of Least developed countries in 1984 to that in 2001?
Offer a very short reply. 0.86. What is the ratio of the Gross enrolment ratio (%) in Equatorial Guinea in 1984 to that in 2001?
Give a very brief answer. 1.84. What is the ratio of the Gross enrolment ratio (%) of Gabon in 1984 to that in 2001?
Keep it short and to the point. 1.07. What is the ratio of the Gross enrolment ratio (%) of Senegal in 1984 to that in 2001?
Your answer should be compact. 0.72. What is the ratio of the Gross enrolment ratio (%) of Least developed countries in 1994 to that in 1999?
Keep it short and to the point. 0.92. What is the ratio of the Gross enrolment ratio (%) of Equatorial Guinea in 1994 to that in 1999?
Ensure brevity in your answer.  1.29. What is the ratio of the Gross enrolment ratio (%) of Gabon in 1994 to that in 1999?
Give a very brief answer. 0.99. What is the ratio of the Gross enrolment ratio (%) in Senegal in 1994 to that in 1999?
Your response must be concise. 0.85. What is the ratio of the Gross enrolment ratio (%) of Least developed countries in 1994 to that in 2001?
Make the answer very short. 0.87. What is the ratio of the Gross enrolment ratio (%) in Equatorial Guinea in 1994 to that in 2001?
Your response must be concise. 1.29. What is the ratio of the Gross enrolment ratio (%) in Gabon in 1994 to that in 2001?
Offer a terse response. 1.03. What is the ratio of the Gross enrolment ratio (%) of Senegal in 1994 to that in 2001?
Provide a short and direct response. 0.79. What is the ratio of the Gross enrolment ratio (%) of Least developed countries in 1999 to that in 2001?
Give a very brief answer. 0.94. What is the ratio of the Gross enrolment ratio (%) in Equatorial Guinea in 1999 to that in 2001?
Offer a terse response. 1. What is the ratio of the Gross enrolment ratio (%) in Gabon in 1999 to that in 2001?
Offer a very short reply. 1.04. What is the ratio of the Gross enrolment ratio (%) in Senegal in 1999 to that in 2001?
Your answer should be very brief. 0.93. What is the difference between the highest and the second highest Gross enrolment ratio (%) of Least developed countries?
Your answer should be very brief. 4.63. What is the difference between the highest and the second highest Gross enrolment ratio (%) of Equatorial Guinea?
Make the answer very short. 36.03. What is the difference between the highest and the second highest Gross enrolment ratio (%) of Gabon?
Provide a short and direct response. 0.8. What is the difference between the highest and the second highest Gross enrolment ratio (%) of Senegal?
Offer a terse response. 5.02. What is the difference between the highest and the lowest Gross enrolment ratio (%) in Least developed countries?
Offer a terse response. 11.01. What is the difference between the highest and the lowest Gross enrolment ratio (%) in Equatorial Guinea?
Your answer should be compact. 94.91. What is the difference between the highest and the lowest Gross enrolment ratio (%) of Gabon?
Your response must be concise. 9.85. What is the difference between the highest and the lowest Gross enrolment ratio (%) in Senegal?
Ensure brevity in your answer.  23.8. 